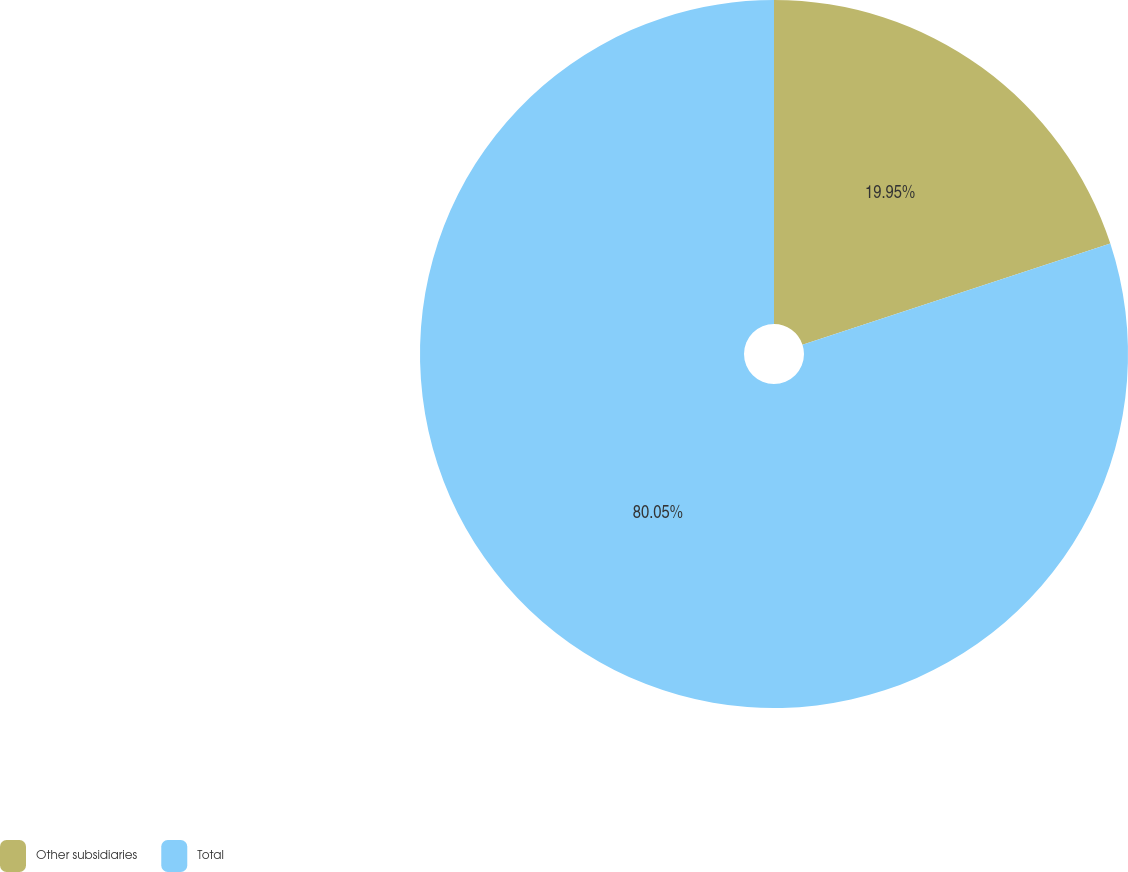<chart> <loc_0><loc_0><loc_500><loc_500><pie_chart><fcel>Other subsidiaries<fcel>Total<nl><fcel>19.95%<fcel>80.05%<nl></chart> 